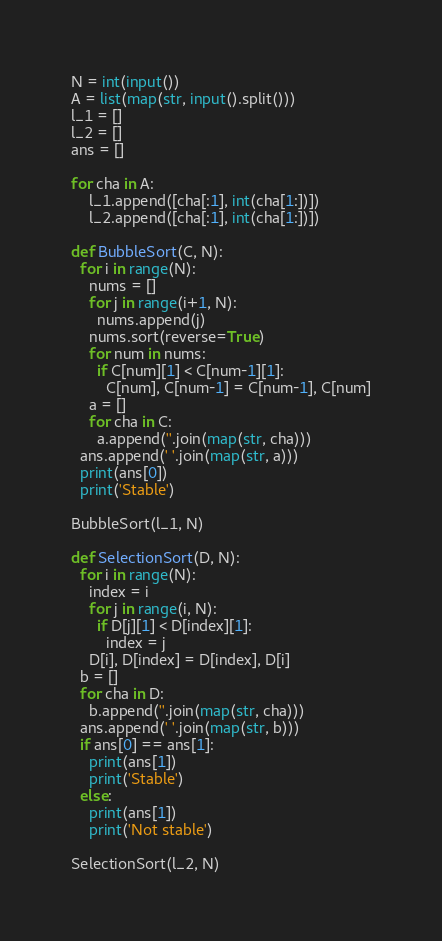<code> <loc_0><loc_0><loc_500><loc_500><_Python_>N = int(input())
A = list(map(str, input().split()))
l_1 = []
l_2 = []
ans = []

for cha in A:
    l_1.append([cha[:1], int(cha[1:])])
    l_2.append([cha[:1], int(cha[1:])])

def BubbleSort(C, N):
  for i in range(N):
    nums = []
    for j in range(i+1, N):
      nums.append(j)
    nums.sort(reverse=True)
    for num in nums:
      if C[num][1] < C[num-1][1]:
        C[num], C[num-1] = C[num-1], C[num]
    a = []
    for cha in C:
      a.append(''.join(map(str, cha)))
  ans.append(' '.join(map(str, a)))
  print(ans[0])
  print('Stable')
  
BubbleSort(l_1, N)

def SelectionSort(D, N):
  for i in range(N):
    index = i
    for j in range(i, N):
      if D[j][1] < D[index][1]:
        index = j
    D[i], D[index] = D[index], D[i]
  b = []
  for cha in D:
    b.append(''.join(map(str, cha)))
  ans.append(' '.join(map(str, b)))
  if ans[0] == ans[1]:
    print(ans[1])
    print('Stable')
  else:
    print(ans[1])
    print('Not stable')

SelectionSort(l_2, N)
</code> 